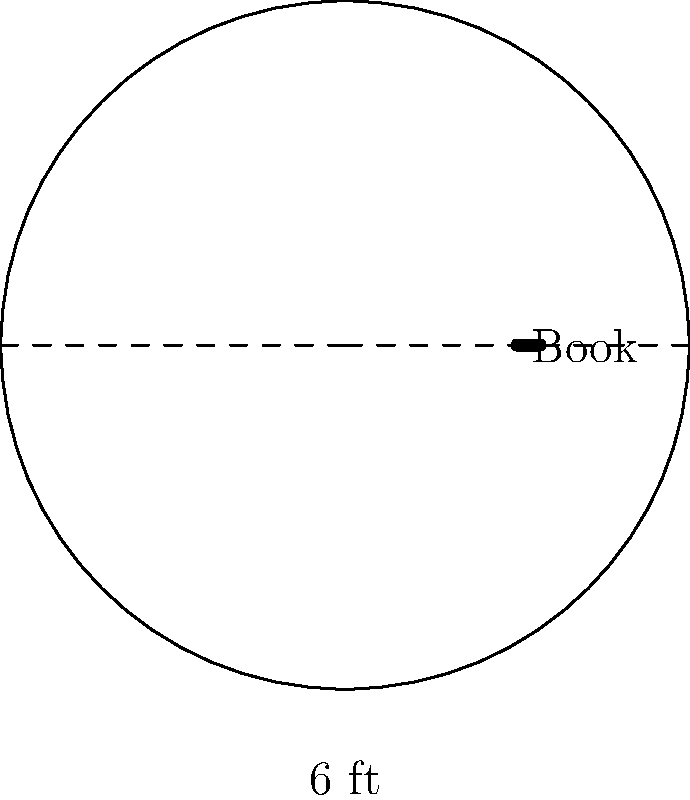You have a circular display table in your library with a diameter of 6 feet. If the average width of a book is 1.5 inches, how many books can you arrange around the perimeter of the table? To solve this problem, let's follow these steps:

1. Calculate the circumference of the table:
   - Diameter = 6 feet
   - Circumference = $\pi \times diameter$
   - Circumference = $\pi \times 6 \approx 18.85$ feet

2. Convert the circumference to inches:
   - 18.85 feet $\times$ 12 inches/foot = 226.2 inches

3. Calculate the number of books:
   - Average book width = 1.5 inches
   - Number of books = Circumference in inches ÷ Book width
   - Number of books = 226.2 ÷ 1.5 = 150.8

4. Round down to the nearest whole number:
   - We can't display partial books, so we round down to 150 books.

Therefore, you can arrange 150 books around the perimeter of the circular display table.
Answer: 150 books 